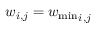Convert formula to latex. <formula><loc_0><loc_0><loc_500><loc_500>w _ { i , j } = { w _ { \min } } _ { i , j }</formula> 